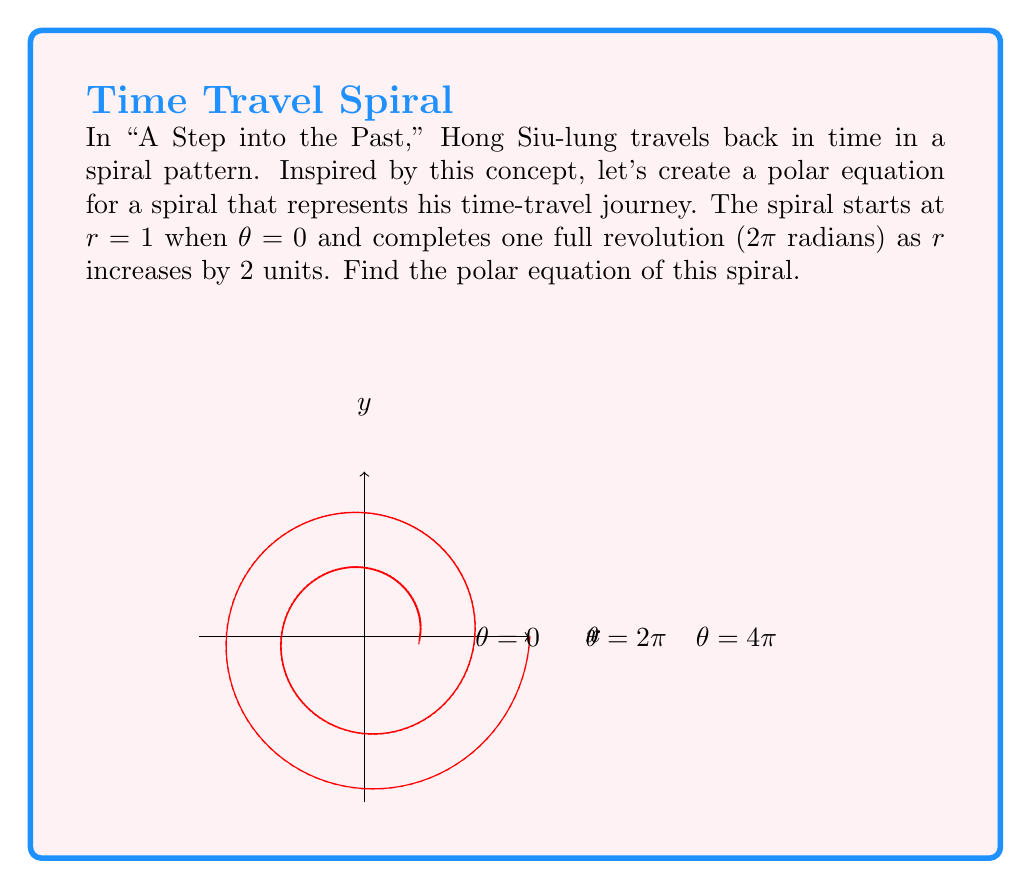Could you help me with this problem? Let's approach this step-by-step:

1) We know that the spiral starts at $r = 1$ when $\theta = 0$. This gives us our initial point.

2) We're told that $r$ increases by 2 units for every full revolution (2π radians) of $\theta$.

3) This suggests a linear relationship between $r$ and $\theta$. We can express this as:

   $r = 1 + k\theta$

   where $k$ is some constant we need to determine.

4) To find $k$, we can use the information about the full revolution:
   When $\theta = 2\pi$, $r$ should be 3 (initial 1 + increase of 2).

5) Substituting these values into our equation:

   $3 = 1 + k(2\pi)$

6) Solving for $k$:

   $2 = k(2\pi)$
   $k = \frac{1}{\pi}$

7) Therefore, our final equation is:

   $r = 1 + \frac{\theta}{\pi}$

This equation represents a spiral that starts at $r = 1$ when $\theta = 0$ and increases by 2 units for every $2\pi$ radians, just like Hong Siu-lung's time-travel pattern in "A Step into the Past".
Answer: $r = 1 + \frac{\theta}{\pi}$ 